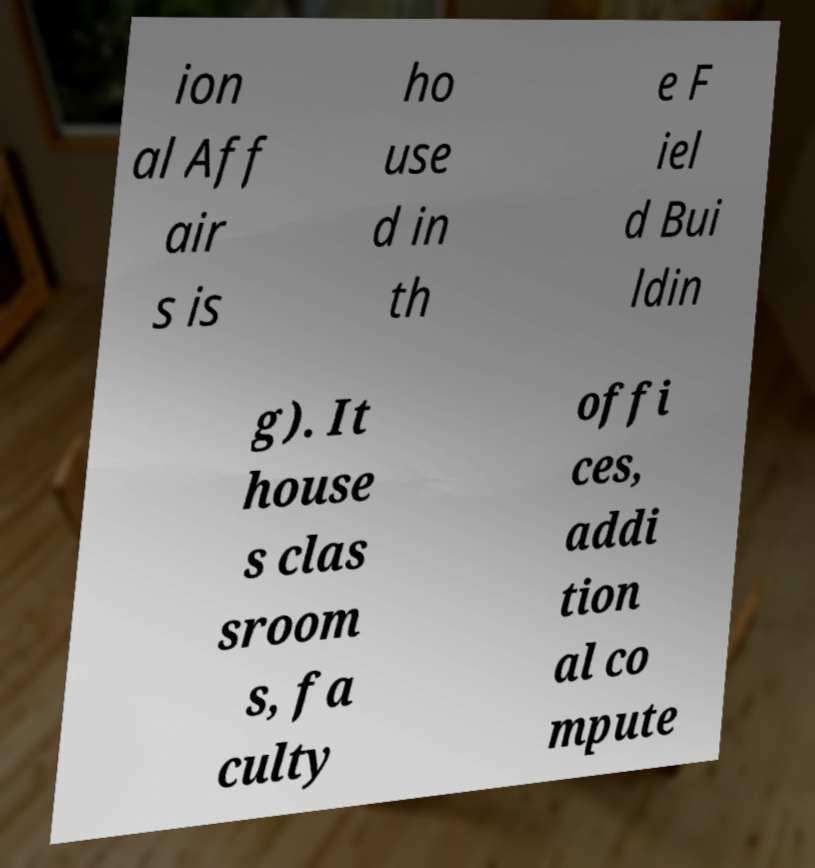Please read and relay the text visible in this image. What does it say? ion al Aff air s is ho use d in th e F iel d Bui ldin g). It house s clas sroom s, fa culty offi ces, addi tion al co mpute 